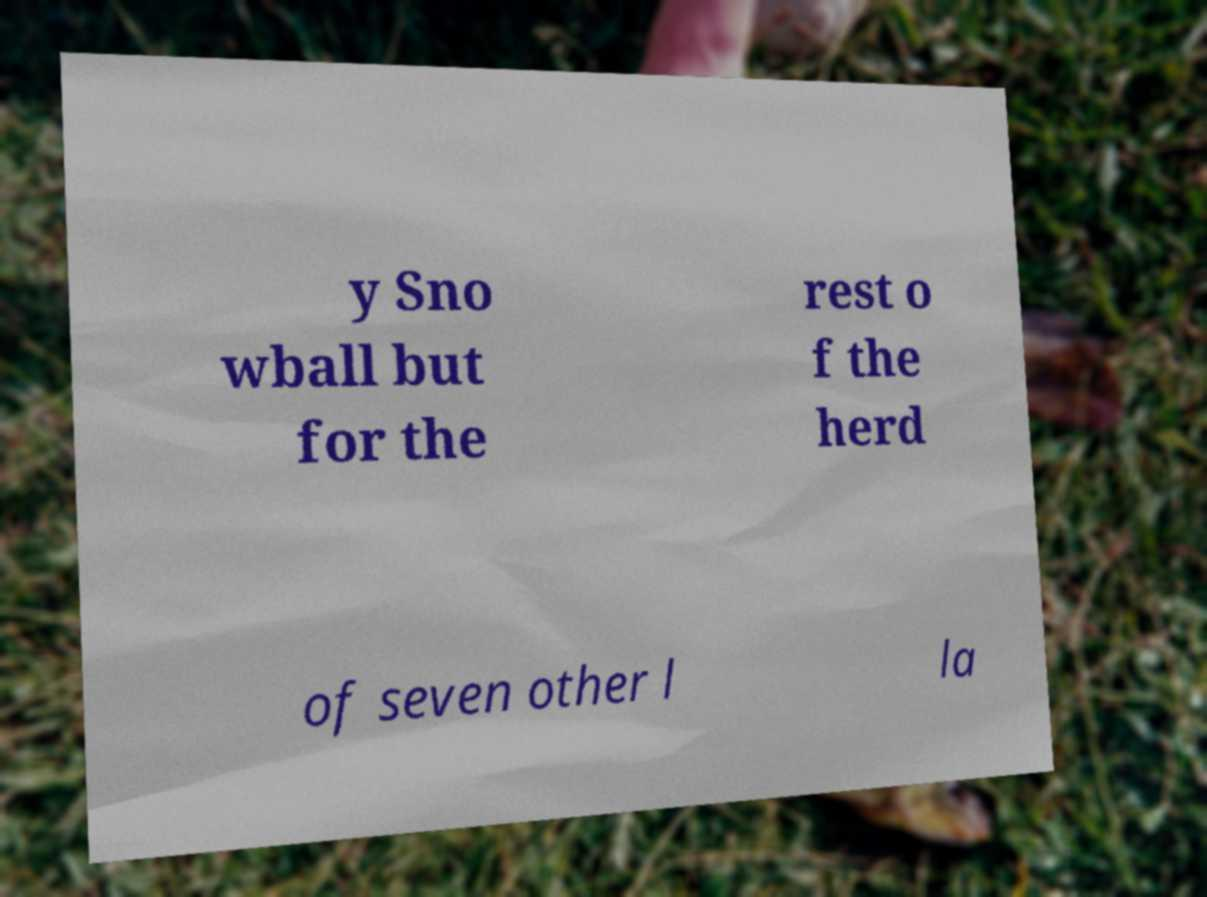Could you extract and type out the text from this image? y Sno wball but for the rest o f the herd of seven other l la 